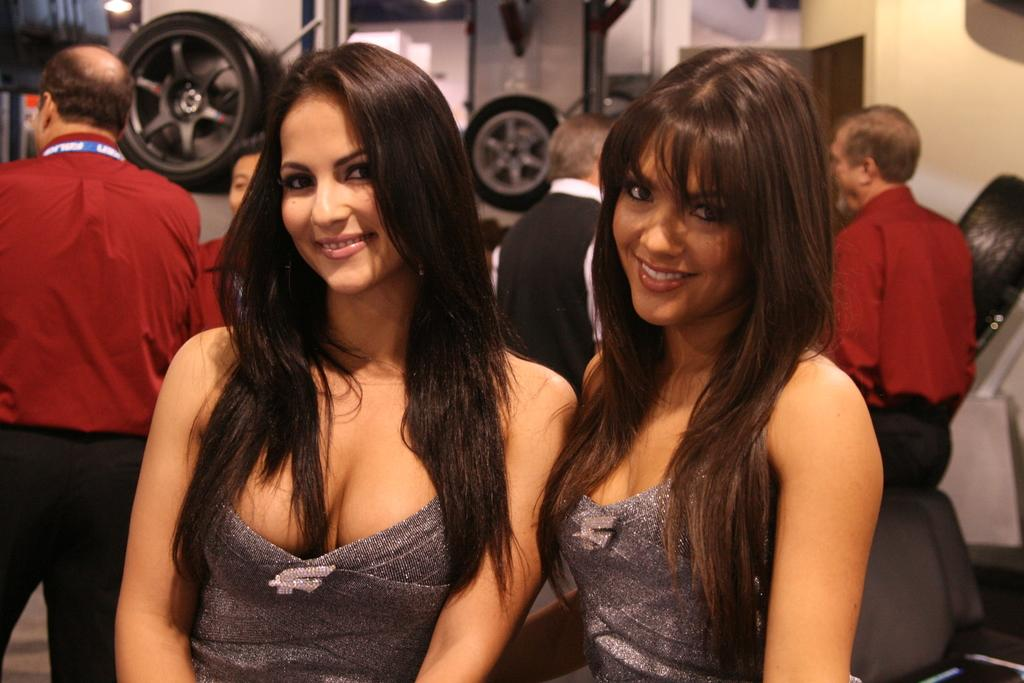How many women are in the image? There are two women in the image. What are the women doing in the image? The women are standing in the front and smiling. What color dress are the women wearing? Both women are wearing grey color dress. Can you describe the men in the image? The men are standing in front of a wall. What is on the wall in the image? The wall has tires on it. What type of air can be seen in the image? There is no air visible in the image; it is a photograph of people standing in front of a wall. How much debt do the women in the image have? There is no information about the women's debt in the image. 